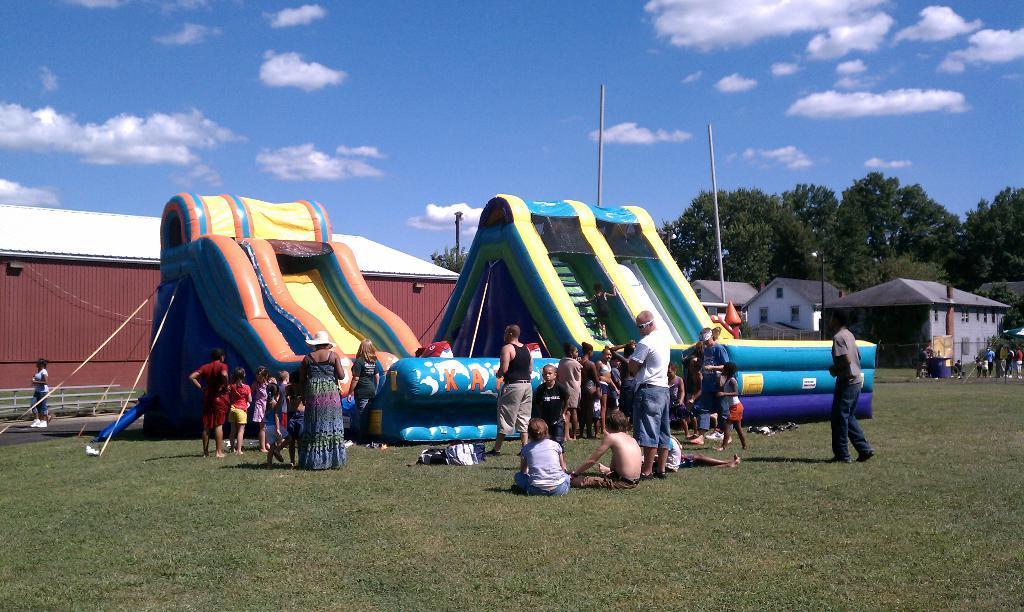Please provide a concise description of this image. As we can see in the image there are inflatables, few people here and there, grass, houses and trees. On the top there is sky and clouds. 